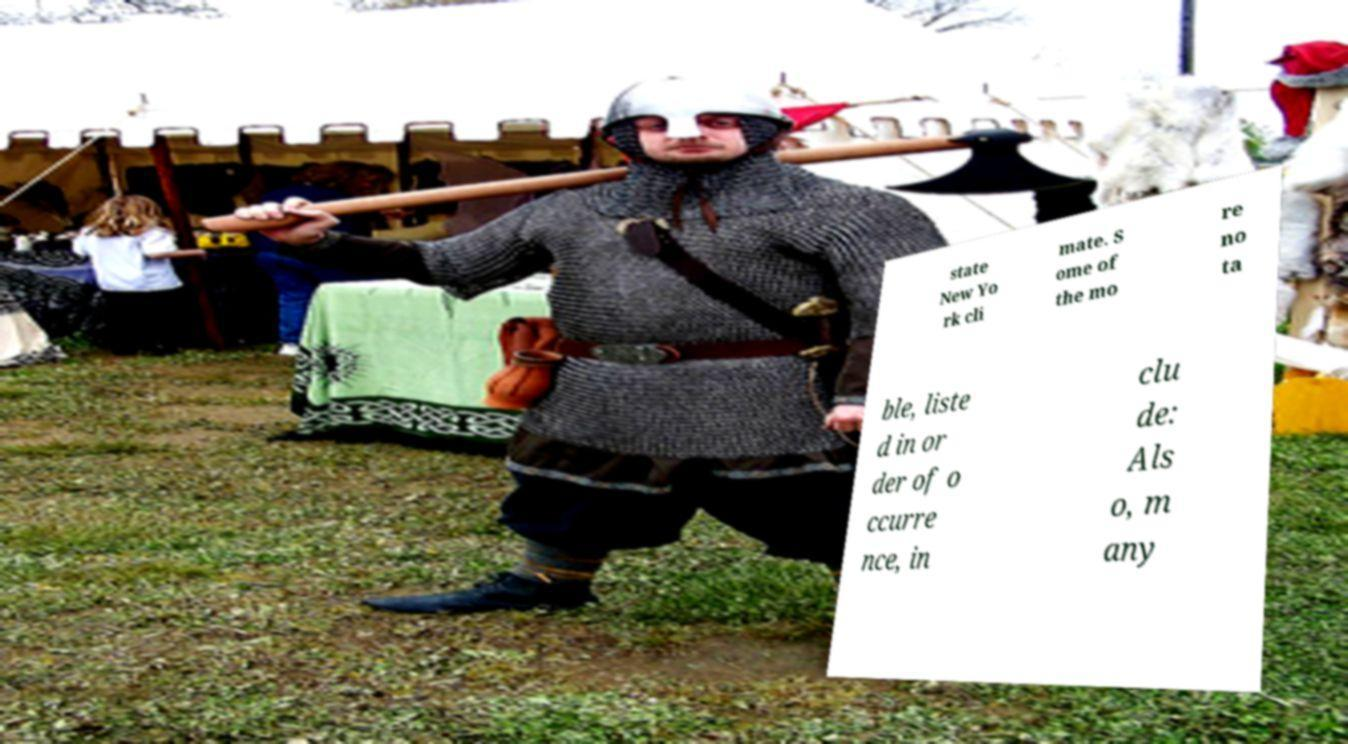Please identify and transcribe the text found in this image. state New Yo rk cli mate. S ome of the mo re no ta ble, liste d in or der of o ccurre nce, in clu de: Als o, m any 